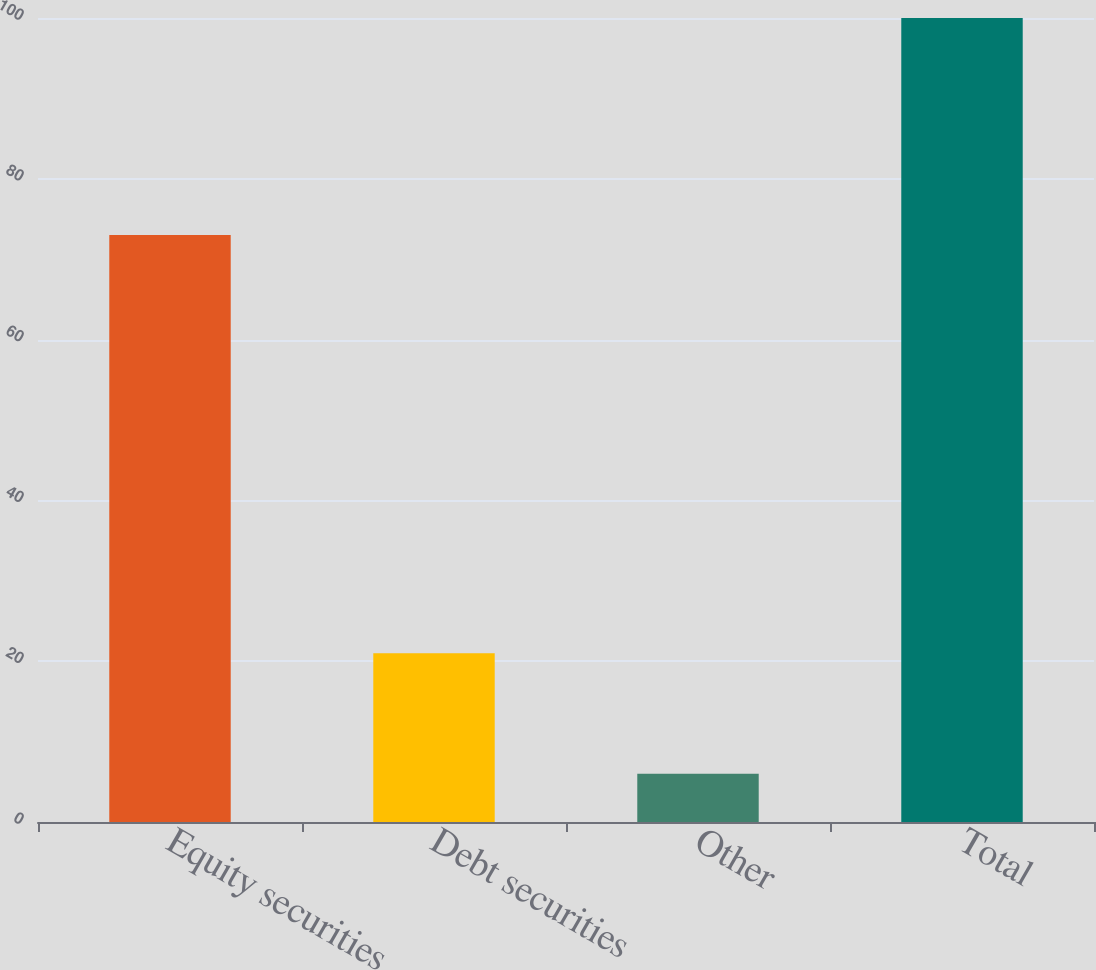Convert chart to OTSL. <chart><loc_0><loc_0><loc_500><loc_500><bar_chart><fcel>Equity securities<fcel>Debt securities<fcel>Other<fcel>Total<nl><fcel>73<fcel>21<fcel>6<fcel>100<nl></chart> 